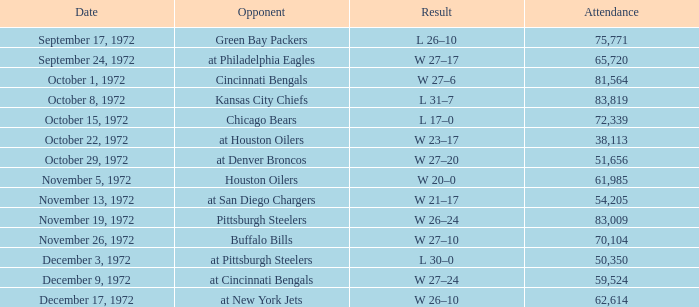What is the sum of week number(s) had an attendance of 61,985? 1.0. 